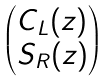Convert formula to latex. <formula><loc_0><loc_0><loc_500><loc_500>\begin{pmatrix} C _ { L } ( z ) \\ S _ { R } ( z ) \end{pmatrix}</formula> 